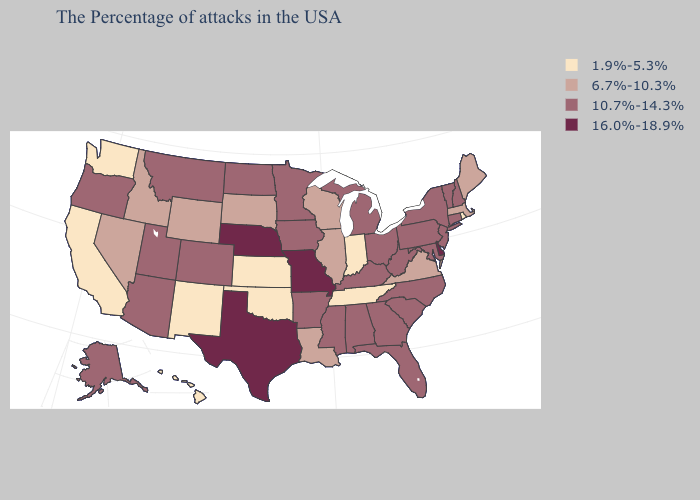Which states have the highest value in the USA?
Keep it brief. Delaware, Missouri, Nebraska, Texas. Does North Dakota have the same value as Maryland?
Answer briefly. Yes. Which states have the lowest value in the South?
Be succinct. Tennessee, Oklahoma. Which states have the lowest value in the South?
Keep it brief. Tennessee, Oklahoma. What is the lowest value in the USA?
Concise answer only. 1.9%-5.3%. Among the states that border Missouri , which have the highest value?
Give a very brief answer. Nebraska. Does Indiana have a lower value than New Hampshire?
Be succinct. Yes. Name the states that have a value in the range 1.9%-5.3%?
Short answer required. Rhode Island, Indiana, Tennessee, Kansas, Oklahoma, New Mexico, California, Washington, Hawaii. What is the value of Virginia?
Short answer required. 6.7%-10.3%. Name the states that have a value in the range 1.9%-5.3%?
Write a very short answer. Rhode Island, Indiana, Tennessee, Kansas, Oklahoma, New Mexico, California, Washington, Hawaii. Does Delaware have the lowest value in the USA?
Short answer required. No. Does the first symbol in the legend represent the smallest category?
Keep it brief. Yes. Name the states that have a value in the range 10.7%-14.3%?
Answer briefly. New Hampshire, Vermont, Connecticut, New York, New Jersey, Maryland, Pennsylvania, North Carolina, South Carolina, West Virginia, Ohio, Florida, Georgia, Michigan, Kentucky, Alabama, Mississippi, Arkansas, Minnesota, Iowa, North Dakota, Colorado, Utah, Montana, Arizona, Oregon, Alaska. Among the states that border Washington , which have the lowest value?
Be succinct. Idaho. Name the states that have a value in the range 6.7%-10.3%?
Keep it brief. Maine, Massachusetts, Virginia, Wisconsin, Illinois, Louisiana, South Dakota, Wyoming, Idaho, Nevada. 